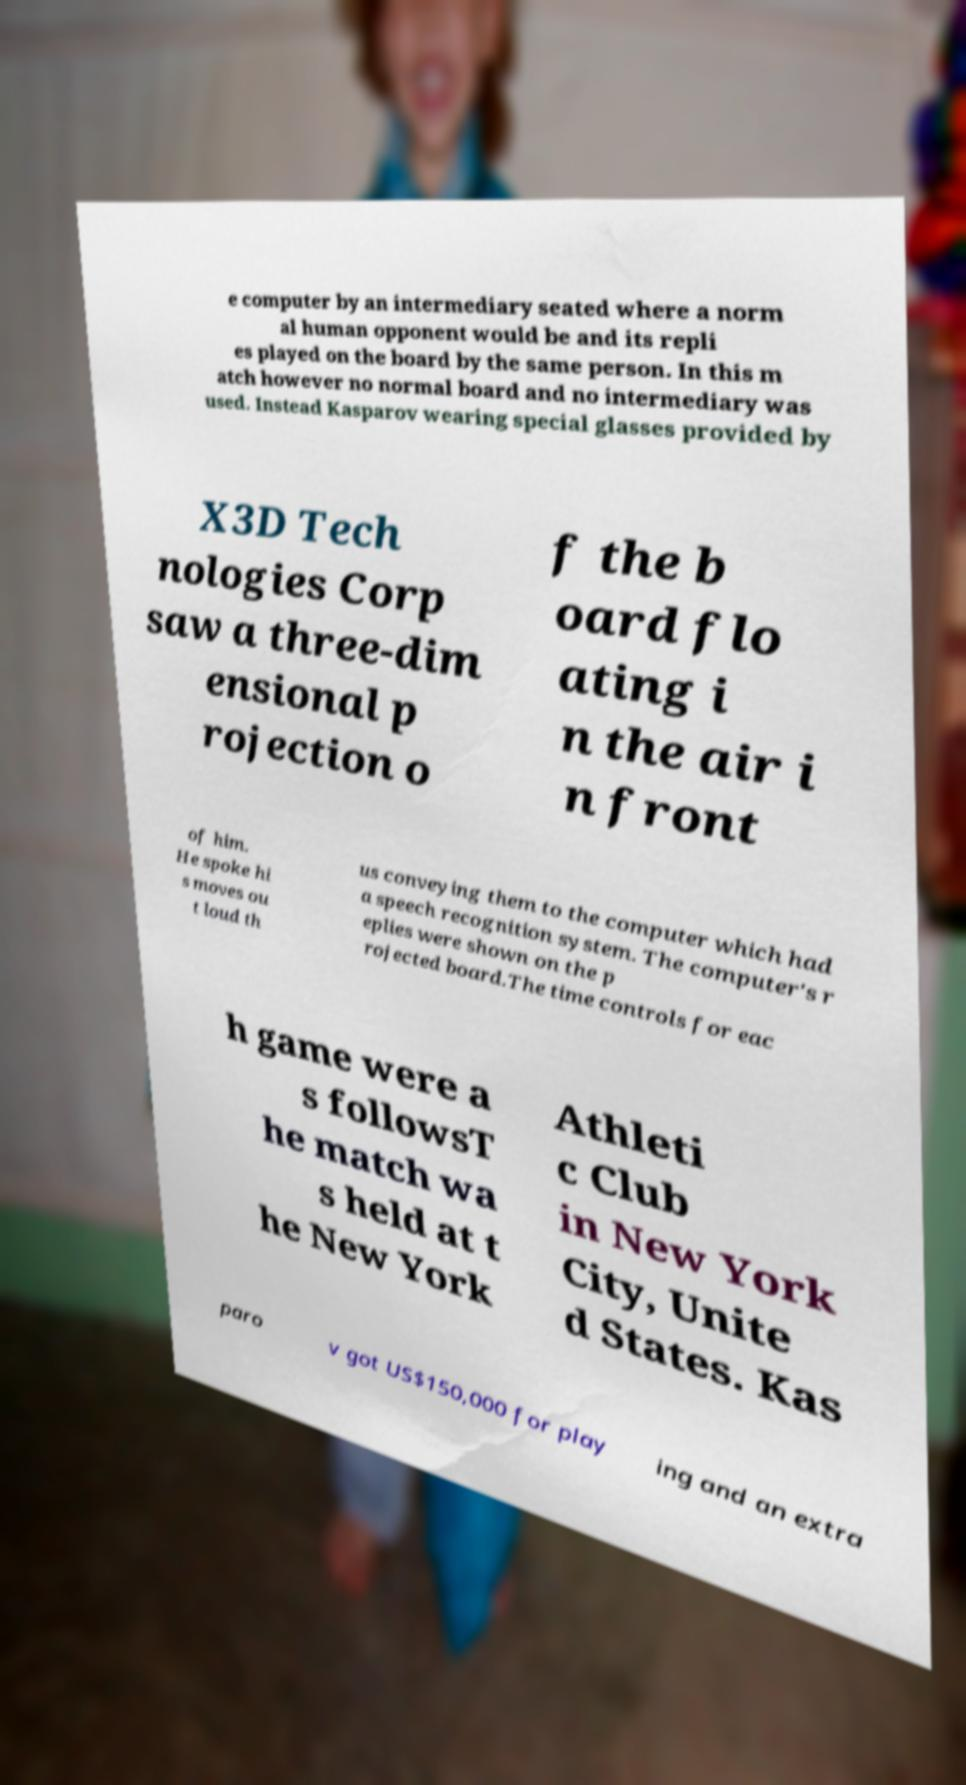Please read and relay the text visible in this image. What does it say? e computer by an intermediary seated where a norm al human opponent would be and its repli es played on the board by the same person. In this m atch however no normal board and no intermediary was used. Instead Kasparov wearing special glasses provided by X3D Tech nologies Corp saw a three-dim ensional p rojection o f the b oard flo ating i n the air i n front of him. He spoke hi s moves ou t loud th us conveying them to the computer which had a speech recognition system. The computer's r eplies were shown on the p rojected board.The time controls for eac h game were a s followsT he match wa s held at t he New York Athleti c Club in New York City, Unite d States. Kas paro v got US$150,000 for play ing and an extra 